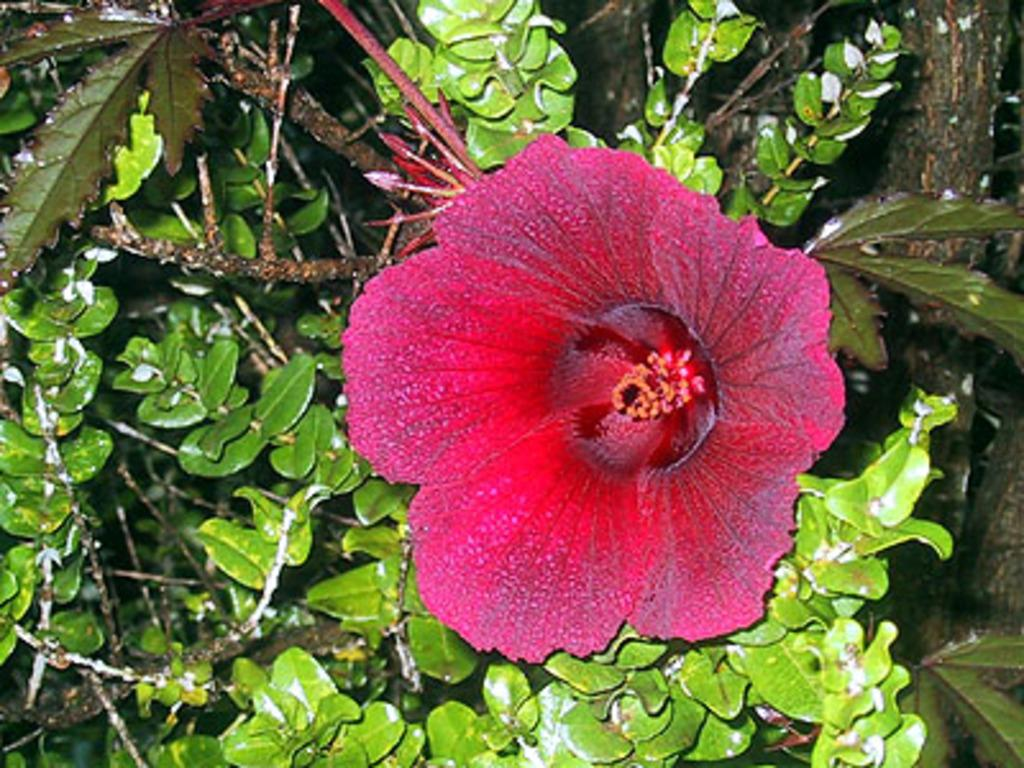What type of plant is visible in the image? There is a plant in the image. What kind of flower does the plant have? The plant has a hibiscus flower. What type of food is being served on the plate in the image? There is no plate or food present in the image; it only features a plant with a hibiscus flower. 